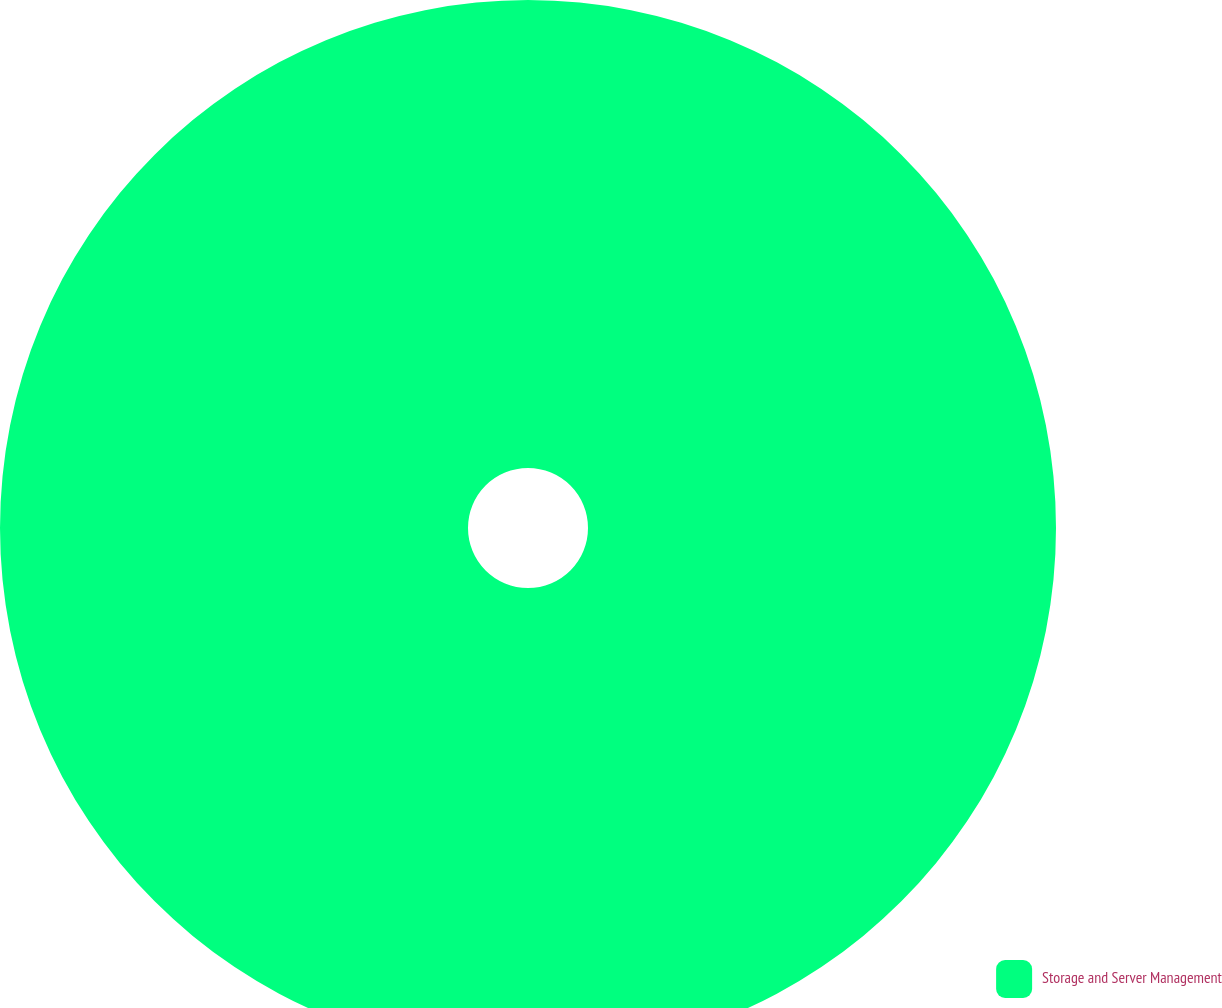<chart> <loc_0><loc_0><loc_500><loc_500><pie_chart><fcel>Storage and Server Management<nl><fcel>100.0%<nl></chart> 